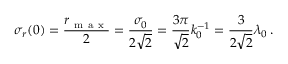<formula> <loc_0><loc_0><loc_500><loc_500>\sigma _ { r } ( 0 ) = \frac { r _ { m a x } } { 2 } = \frac { \sigma _ { 0 } } { 2 \sqrt { 2 } } = \frac { 3 \pi } { \sqrt { 2 } } k _ { 0 } ^ { - 1 } = \frac { 3 } { 2 \sqrt { 2 } } \lambda _ { 0 } \, .</formula> 